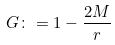<formula> <loc_0><loc_0><loc_500><loc_500>G \colon = 1 - \frac { 2 M } { r }</formula> 